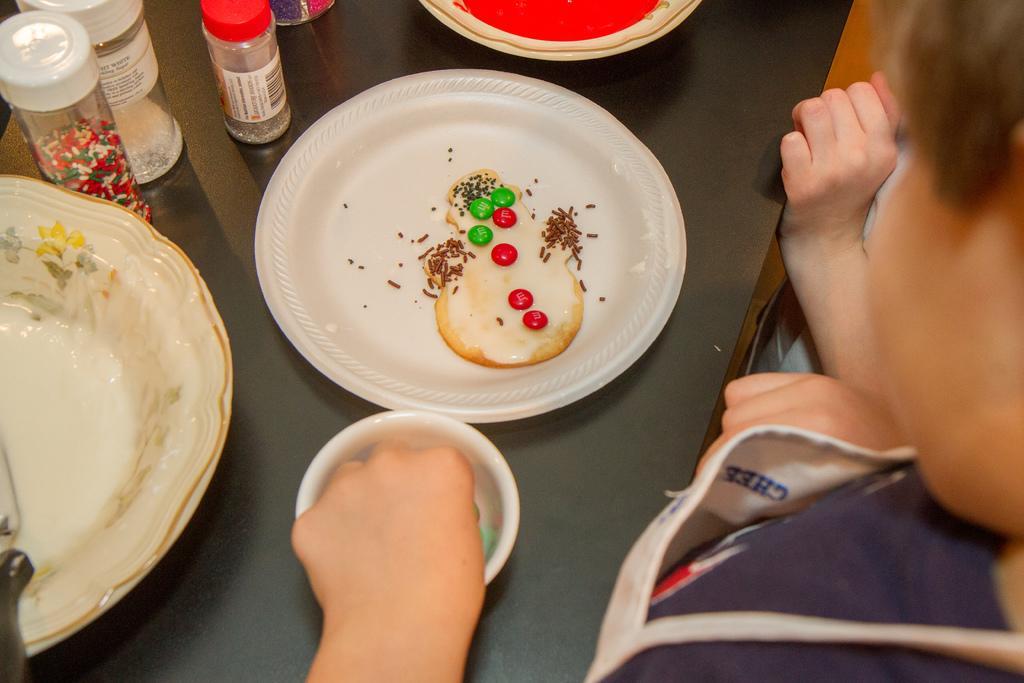Describe this image in one or two sentences. In the foreground of this image, on the right, there are two persons standing in front of a table on which platters and a platter with food, bowl and few containers on it. 